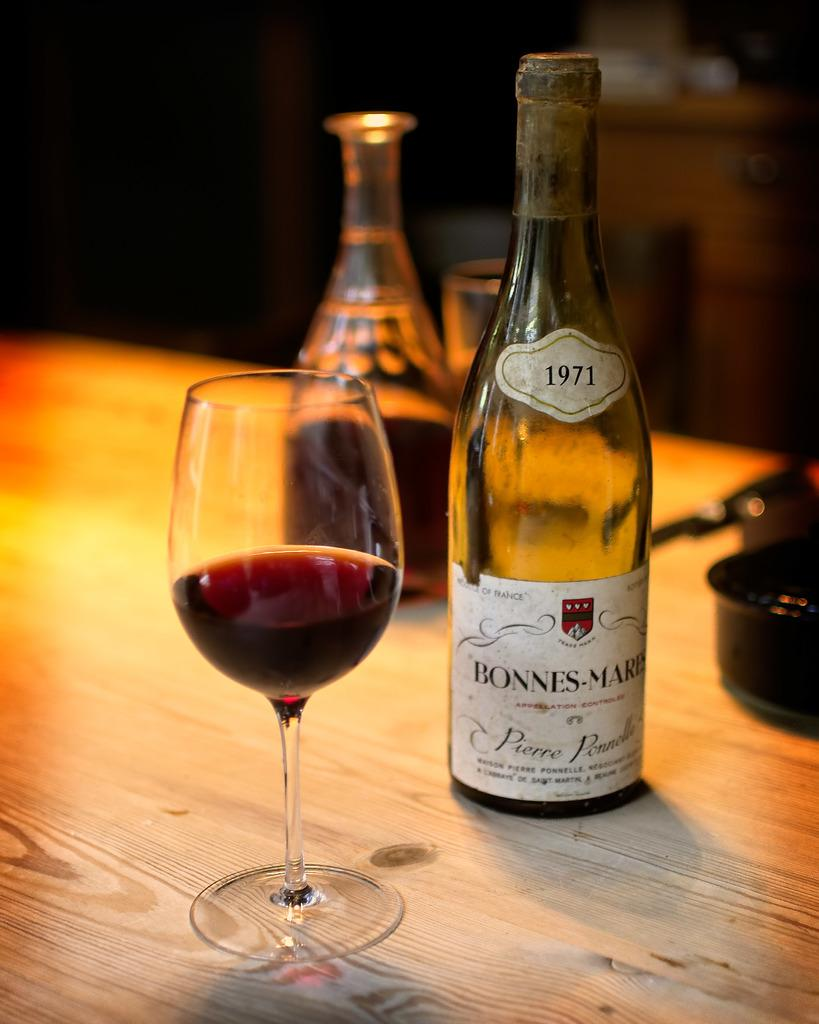What type of table is in the image? There is a wooden table in the image. What is on the table? There is a wine glass and a wine bottle on the table. What else is on the table? There is a bottle on the right side of the table. Can you describe the bottle on the right side of the table? There is a sticker on the bottle. What else can be seen in the image? There is a pan in the image. What is the name of the snail crawling on the wine glass in the image? There is no snail present in the image, so it is not possible to determine its name. 